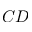Convert formula to latex. <formula><loc_0><loc_0><loc_500><loc_500>C D</formula> 